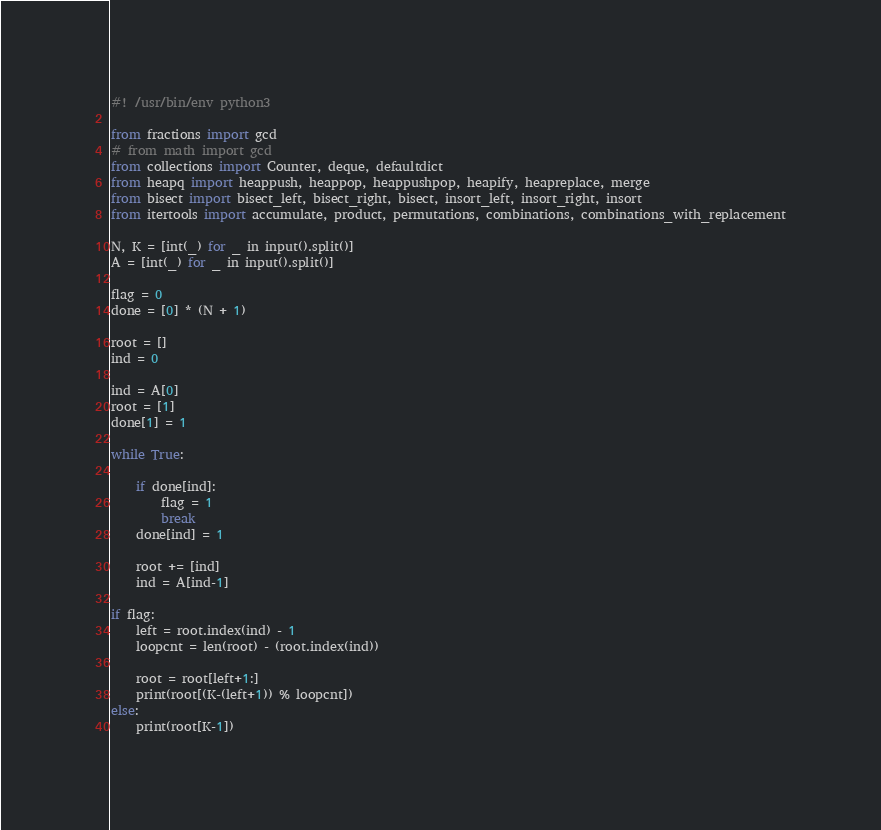<code> <loc_0><loc_0><loc_500><loc_500><_Python_>#! /usr/bin/env python3

from fractions import gcd
# from math import gcd
from collections import Counter, deque, defaultdict
from heapq import heappush, heappop, heappushpop, heapify, heapreplace, merge
from bisect import bisect_left, bisect_right, bisect, insort_left, insort_right, insort
from itertools import accumulate, product, permutations, combinations, combinations_with_replacement

N, K = [int(_) for _ in input().split()]
A = [int(_) for _ in input().split()]

flag = 0
done = [0] * (N + 1)

root = []
ind = 0

ind = A[0]
root = [1]
done[1] = 1

while True:
    
    if done[ind]:
        flag = 1
        break
    done[ind] = 1
    
    root += [ind]
    ind = A[ind-1]

if flag:
    left = root.index(ind) - 1
    loopcnt = len(root) - (root.index(ind))

    root = root[left+1:]
    print(root[(K-(left+1)) % loopcnt])
else:
    print(root[K-1])

</code> 